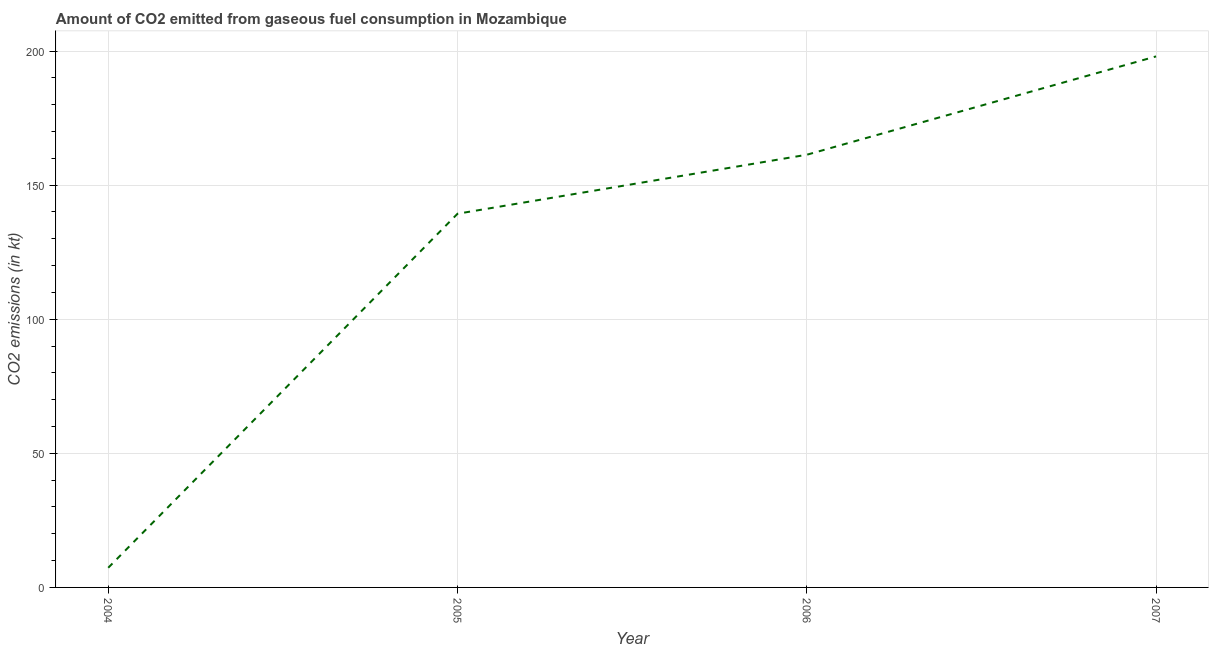What is the co2 emissions from gaseous fuel consumption in 2006?
Your answer should be compact. 161.35. Across all years, what is the maximum co2 emissions from gaseous fuel consumption?
Ensure brevity in your answer.  198.02. Across all years, what is the minimum co2 emissions from gaseous fuel consumption?
Provide a short and direct response. 7.33. What is the sum of the co2 emissions from gaseous fuel consumption?
Give a very brief answer. 506.05. What is the difference between the co2 emissions from gaseous fuel consumption in 2005 and 2007?
Ensure brevity in your answer.  -58.67. What is the average co2 emissions from gaseous fuel consumption per year?
Your answer should be compact. 126.51. What is the median co2 emissions from gaseous fuel consumption?
Ensure brevity in your answer.  150.35. Do a majority of the years between 2006 and 2005 (inclusive) have co2 emissions from gaseous fuel consumption greater than 20 kt?
Your answer should be very brief. No. What is the ratio of the co2 emissions from gaseous fuel consumption in 2006 to that in 2007?
Provide a short and direct response. 0.81. Is the difference between the co2 emissions from gaseous fuel consumption in 2005 and 2006 greater than the difference between any two years?
Your response must be concise. No. What is the difference between the highest and the second highest co2 emissions from gaseous fuel consumption?
Provide a short and direct response. 36.67. What is the difference between the highest and the lowest co2 emissions from gaseous fuel consumption?
Offer a very short reply. 190.68. In how many years, is the co2 emissions from gaseous fuel consumption greater than the average co2 emissions from gaseous fuel consumption taken over all years?
Provide a succinct answer. 3. Does the graph contain any zero values?
Provide a short and direct response. No. Does the graph contain grids?
Provide a succinct answer. Yes. What is the title of the graph?
Ensure brevity in your answer.  Amount of CO2 emitted from gaseous fuel consumption in Mozambique. What is the label or title of the Y-axis?
Make the answer very short. CO2 emissions (in kt). What is the CO2 emissions (in kt) of 2004?
Your response must be concise. 7.33. What is the CO2 emissions (in kt) in 2005?
Offer a very short reply. 139.35. What is the CO2 emissions (in kt) in 2006?
Make the answer very short. 161.35. What is the CO2 emissions (in kt) in 2007?
Ensure brevity in your answer.  198.02. What is the difference between the CO2 emissions (in kt) in 2004 and 2005?
Give a very brief answer. -132.01. What is the difference between the CO2 emissions (in kt) in 2004 and 2006?
Ensure brevity in your answer.  -154.01. What is the difference between the CO2 emissions (in kt) in 2004 and 2007?
Make the answer very short. -190.68. What is the difference between the CO2 emissions (in kt) in 2005 and 2006?
Keep it short and to the point. -22. What is the difference between the CO2 emissions (in kt) in 2005 and 2007?
Your response must be concise. -58.67. What is the difference between the CO2 emissions (in kt) in 2006 and 2007?
Offer a very short reply. -36.67. What is the ratio of the CO2 emissions (in kt) in 2004 to that in 2005?
Provide a short and direct response. 0.05. What is the ratio of the CO2 emissions (in kt) in 2004 to that in 2006?
Your answer should be compact. 0.04. What is the ratio of the CO2 emissions (in kt) in 2004 to that in 2007?
Offer a very short reply. 0.04. What is the ratio of the CO2 emissions (in kt) in 2005 to that in 2006?
Keep it short and to the point. 0.86. What is the ratio of the CO2 emissions (in kt) in 2005 to that in 2007?
Ensure brevity in your answer.  0.7. What is the ratio of the CO2 emissions (in kt) in 2006 to that in 2007?
Provide a succinct answer. 0.81. 